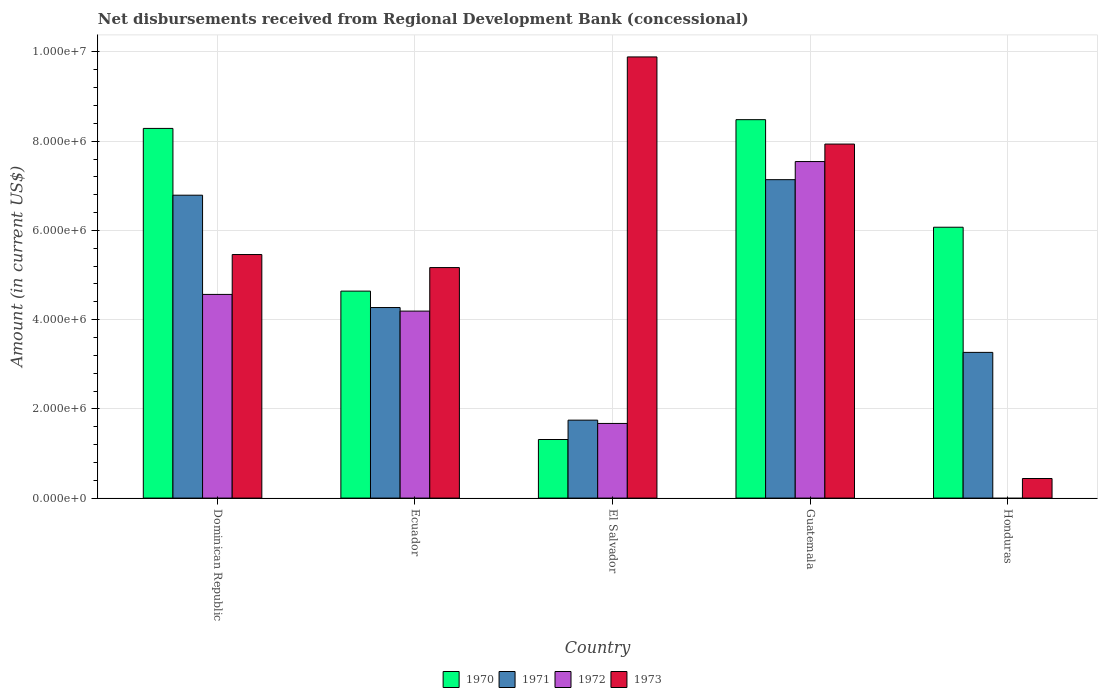How many groups of bars are there?
Your response must be concise. 5. Are the number of bars per tick equal to the number of legend labels?
Your answer should be compact. No. Are the number of bars on each tick of the X-axis equal?
Offer a terse response. No. How many bars are there on the 2nd tick from the left?
Make the answer very short. 4. What is the label of the 1st group of bars from the left?
Offer a very short reply. Dominican Republic. What is the amount of disbursements received from Regional Development Bank in 1970 in Ecuador?
Offer a very short reply. 4.64e+06. Across all countries, what is the maximum amount of disbursements received from Regional Development Bank in 1970?
Your answer should be compact. 8.48e+06. In which country was the amount of disbursements received from Regional Development Bank in 1973 maximum?
Your response must be concise. El Salvador. What is the total amount of disbursements received from Regional Development Bank in 1973 in the graph?
Your answer should be very brief. 2.89e+07. What is the difference between the amount of disbursements received from Regional Development Bank in 1973 in Ecuador and that in Guatemala?
Provide a short and direct response. -2.77e+06. What is the difference between the amount of disbursements received from Regional Development Bank in 1971 in Guatemala and the amount of disbursements received from Regional Development Bank in 1972 in Dominican Republic?
Your answer should be compact. 2.57e+06. What is the average amount of disbursements received from Regional Development Bank in 1973 per country?
Your answer should be compact. 5.78e+06. What is the difference between the amount of disbursements received from Regional Development Bank of/in 1971 and amount of disbursements received from Regional Development Bank of/in 1972 in Ecuador?
Keep it short and to the point. 8.00e+04. What is the ratio of the amount of disbursements received from Regional Development Bank in 1973 in El Salvador to that in Honduras?
Ensure brevity in your answer.  22.52. Is the difference between the amount of disbursements received from Regional Development Bank in 1971 in Dominican Republic and Ecuador greater than the difference between the amount of disbursements received from Regional Development Bank in 1972 in Dominican Republic and Ecuador?
Your answer should be compact. Yes. What is the difference between the highest and the second highest amount of disbursements received from Regional Development Bank in 1970?
Keep it short and to the point. 1.96e+05. What is the difference between the highest and the lowest amount of disbursements received from Regional Development Bank in 1971?
Provide a short and direct response. 5.39e+06. In how many countries, is the amount of disbursements received from Regional Development Bank in 1972 greater than the average amount of disbursements received from Regional Development Bank in 1972 taken over all countries?
Your answer should be compact. 3. How many countries are there in the graph?
Give a very brief answer. 5. What is the difference between two consecutive major ticks on the Y-axis?
Your answer should be very brief. 2.00e+06. Does the graph contain any zero values?
Offer a very short reply. Yes. Where does the legend appear in the graph?
Provide a short and direct response. Bottom center. How are the legend labels stacked?
Provide a short and direct response. Horizontal. What is the title of the graph?
Offer a terse response. Net disbursements received from Regional Development Bank (concessional). Does "1964" appear as one of the legend labels in the graph?
Provide a succinct answer. No. What is the label or title of the X-axis?
Ensure brevity in your answer.  Country. What is the label or title of the Y-axis?
Make the answer very short. Amount (in current US$). What is the Amount (in current US$) of 1970 in Dominican Republic?
Ensure brevity in your answer.  8.29e+06. What is the Amount (in current US$) of 1971 in Dominican Republic?
Offer a very short reply. 6.79e+06. What is the Amount (in current US$) in 1972 in Dominican Republic?
Provide a succinct answer. 4.56e+06. What is the Amount (in current US$) in 1973 in Dominican Republic?
Your answer should be compact. 5.46e+06. What is the Amount (in current US$) in 1970 in Ecuador?
Your answer should be very brief. 4.64e+06. What is the Amount (in current US$) in 1971 in Ecuador?
Ensure brevity in your answer.  4.27e+06. What is the Amount (in current US$) in 1972 in Ecuador?
Give a very brief answer. 4.19e+06. What is the Amount (in current US$) in 1973 in Ecuador?
Give a very brief answer. 5.17e+06. What is the Amount (in current US$) in 1970 in El Salvador?
Provide a short and direct response. 1.31e+06. What is the Amount (in current US$) in 1971 in El Salvador?
Offer a terse response. 1.75e+06. What is the Amount (in current US$) of 1972 in El Salvador?
Ensure brevity in your answer.  1.67e+06. What is the Amount (in current US$) in 1973 in El Salvador?
Provide a succinct answer. 9.89e+06. What is the Amount (in current US$) of 1970 in Guatemala?
Your response must be concise. 8.48e+06. What is the Amount (in current US$) in 1971 in Guatemala?
Keep it short and to the point. 7.14e+06. What is the Amount (in current US$) of 1972 in Guatemala?
Provide a short and direct response. 7.54e+06. What is the Amount (in current US$) of 1973 in Guatemala?
Provide a succinct answer. 7.94e+06. What is the Amount (in current US$) in 1970 in Honduras?
Offer a very short reply. 6.07e+06. What is the Amount (in current US$) of 1971 in Honduras?
Your answer should be compact. 3.27e+06. What is the Amount (in current US$) of 1973 in Honduras?
Your response must be concise. 4.39e+05. Across all countries, what is the maximum Amount (in current US$) of 1970?
Your answer should be very brief. 8.48e+06. Across all countries, what is the maximum Amount (in current US$) in 1971?
Ensure brevity in your answer.  7.14e+06. Across all countries, what is the maximum Amount (in current US$) in 1972?
Keep it short and to the point. 7.54e+06. Across all countries, what is the maximum Amount (in current US$) in 1973?
Keep it short and to the point. 9.89e+06. Across all countries, what is the minimum Amount (in current US$) in 1970?
Provide a succinct answer. 1.31e+06. Across all countries, what is the minimum Amount (in current US$) of 1971?
Keep it short and to the point. 1.75e+06. Across all countries, what is the minimum Amount (in current US$) in 1973?
Your response must be concise. 4.39e+05. What is the total Amount (in current US$) in 1970 in the graph?
Keep it short and to the point. 2.88e+07. What is the total Amount (in current US$) of 1971 in the graph?
Make the answer very short. 2.32e+07. What is the total Amount (in current US$) in 1972 in the graph?
Provide a succinct answer. 1.80e+07. What is the total Amount (in current US$) in 1973 in the graph?
Your answer should be compact. 2.89e+07. What is the difference between the Amount (in current US$) in 1970 in Dominican Republic and that in Ecuador?
Give a very brief answer. 3.65e+06. What is the difference between the Amount (in current US$) in 1971 in Dominican Republic and that in Ecuador?
Provide a succinct answer. 2.52e+06. What is the difference between the Amount (in current US$) in 1972 in Dominican Republic and that in Ecuador?
Provide a short and direct response. 3.74e+05. What is the difference between the Amount (in current US$) in 1973 in Dominican Republic and that in Ecuador?
Give a very brief answer. 2.92e+05. What is the difference between the Amount (in current US$) in 1970 in Dominican Republic and that in El Salvador?
Provide a short and direct response. 6.97e+06. What is the difference between the Amount (in current US$) of 1971 in Dominican Republic and that in El Salvador?
Provide a short and direct response. 5.04e+06. What is the difference between the Amount (in current US$) in 1972 in Dominican Republic and that in El Salvador?
Make the answer very short. 2.89e+06. What is the difference between the Amount (in current US$) of 1973 in Dominican Republic and that in El Salvador?
Your response must be concise. -4.43e+06. What is the difference between the Amount (in current US$) in 1970 in Dominican Republic and that in Guatemala?
Your answer should be very brief. -1.96e+05. What is the difference between the Amount (in current US$) in 1971 in Dominican Republic and that in Guatemala?
Your answer should be very brief. -3.48e+05. What is the difference between the Amount (in current US$) of 1972 in Dominican Republic and that in Guatemala?
Make the answer very short. -2.98e+06. What is the difference between the Amount (in current US$) of 1973 in Dominican Republic and that in Guatemala?
Keep it short and to the point. -2.48e+06. What is the difference between the Amount (in current US$) of 1970 in Dominican Republic and that in Honduras?
Make the answer very short. 2.22e+06. What is the difference between the Amount (in current US$) of 1971 in Dominican Republic and that in Honduras?
Provide a short and direct response. 3.52e+06. What is the difference between the Amount (in current US$) of 1973 in Dominican Republic and that in Honduras?
Ensure brevity in your answer.  5.02e+06. What is the difference between the Amount (in current US$) of 1970 in Ecuador and that in El Salvador?
Offer a very short reply. 3.33e+06. What is the difference between the Amount (in current US$) of 1971 in Ecuador and that in El Salvador?
Your answer should be compact. 2.52e+06. What is the difference between the Amount (in current US$) in 1972 in Ecuador and that in El Salvador?
Provide a short and direct response. 2.52e+06. What is the difference between the Amount (in current US$) of 1973 in Ecuador and that in El Salvador?
Your answer should be compact. -4.72e+06. What is the difference between the Amount (in current US$) of 1970 in Ecuador and that in Guatemala?
Your answer should be compact. -3.84e+06. What is the difference between the Amount (in current US$) in 1971 in Ecuador and that in Guatemala?
Your answer should be very brief. -2.87e+06. What is the difference between the Amount (in current US$) in 1972 in Ecuador and that in Guatemala?
Your response must be concise. -3.35e+06. What is the difference between the Amount (in current US$) in 1973 in Ecuador and that in Guatemala?
Provide a succinct answer. -2.77e+06. What is the difference between the Amount (in current US$) in 1970 in Ecuador and that in Honduras?
Keep it short and to the point. -1.43e+06. What is the difference between the Amount (in current US$) in 1971 in Ecuador and that in Honduras?
Make the answer very short. 1.00e+06. What is the difference between the Amount (in current US$) of 1973 in Ecuador and that in Honduras?
Provide a short and direct response. 4.73e+06. What is the difference between the Amount (in current US$) in 1970 in El Salvador and that in Guatemala?
Your answer should be compact. -7.17e+06. What is the difference between the Amount (in current US$) in 1971 in El Salvador and that in Guatemala?
Your response must be concise. -5.39e+06. What is the difference between the Amount (in current US$) of 1972 in El Salvador and that in Guatemala?
Keep it short and to the point. -5.87e+06. What is the difference between the Amount (in current US$) in 1973 in El Salvador and that in Guatemala?
Provide a succinct answer. 1.95e+06. What is the difference between the Amount (in current US$) in 1970 in El Salvador and that in Honduras?
Offer a very short reply. -4.76e+06. What is the difference between the Amount (in current US$) of 1971 in El Salvador and that in Honduras?
Give a very brief answer. -1.52e+06. What is the difference between the Amount (in current US$) in 1973 in El Salvador and that in Honduras?
Ensure brevity in your answer.  9.45e+06. What is the difference between the Amount (in current US$) of 1970 in Guatemala and that in Honduras?
Provide a short and direct response. 2.41e+06. What is the difference between the Amount (in current US$) in 1971 in Guatemala and that in Honduras?
Your answer should be very brief. 3.87e+06. What is the difference between the Amount (in current US$) in 1973 in Guatemala and that in Honduras?
Give a very brief answer. 7.50e+06. What is the difference between the Amount (in current US$) in 1970 in Dominican Republic and the Amount (in current US$) in 1971 in Ecuador?
Give a very brief answer. 4.02e+06. What is the difference between the Amount (in current US$) in 1970 in Dominican Republic and the Amount (in current US$) in 1972 in Ecuador?
Your answer should be very brief. 4.10e+06. What is the difference between the Amount (in current US$) in 1970 in Dominican Republic and the Amount (in current US$) in 1973 in Ecuador?
Provide a succinct answer. 3.12e+06. What is the difference between the Amount (in current US$) of 1971 in Dominican Republic and the Amount (in current US$) of 1972 in Ecuador?
Make the answer very short. 2.60e+06. What is the difference between the Amount (in current US$) in 1971 in Dominican Republic and the Amount (in current US$) in 1973 in Ecuador?
Your answer should be compact. 1.62e+06. What is the difference between the Amount (in current US$) of 1972 in Dominican Republic and the Amount (in current US$) of 1973 in Ecuador?
Give a very brief answer. -6.02e+05. What is the difference between the Amount (in current US$) of 1970 in Dominican Republic and the Amount (in current US$) of 1971 in El Salvador?
Give a very brief answer. 6.54e+06. What is the difference between the Amount (in current US$) in 1970 in Dominican Republic and the Amount (in current US$) in 1972 in El Salvador?
Provide a succinct answer. 6.61e+06. What is the difference between the Amount (in current US$) of 1970 in Dominican Republic and the Amount (in current US$) of 1973 in El Salvador?
Make the answer very short. -1.60e+06. What is the difference between the Amount (in current US$) in 1971 in Dominican Republic and the Amount (in current US$) in 1972 in El Salvador?
Your response must be concise. 5.12e+06. What is the difference between the Amount (in current US$) of 1971 in Dominican Republic and the Amount (in current US$) of 1973 in El Salvador?
Keep it short and to the point. -3.10e+06. What is the difference between the Amount (in current US$) in 1972 in Dominican Republic and the Amount (in current US$) in 1973 in El Salvador?
Make the answer very short. -5.32e+06. What is the difference between the Amount (in current US$) of 1970 in Dominican Republic and the Amount (in current US$) of 1971 in Guatemala?
Your answer should be compact. 1.15e+06. What is the difference between the Amount (in current US$) in 1970 in Dominican Republic and the Amount (in current US$) in 1972 in Guatemala?
Keep it short and to the point. 7.43e+05. What is the difference between the Amount (in current US$) of 1970 in Dominican Republic and the Amount (in current US$) of 1973 in Guatemala?
Offer a terse response. 3.51e+05. What is the difference between the Amount (in current US$) of 1971 in Dominican Republic and the Amount (in current US$) of 1972 in Guatemala?
Keep it short and to the point. -7.54e+05. What is the difference between the Amount (in current US$) of 1971 in Dominican Republic and the Amount (in current US$) of 1973 in Guatemala?
Your response must be concise. -1.15e+06. What is the difference between the Amount (in current US$) of 1972 in Dominican Republic and the Amount (in current US$) of 1973 in Guatemala?
Your answer should be compact. -3.37e+06. What is the difference between the Amount (in current US$) in 1970 in Dominican Republic and the Amount (in current US$) in 1971 in Honduras?
Give a very brief answer. 5.02e+06. What is the difference between the Amount (in current US$) in 1970 in Dominican Republic and the Amount (in current US$) in 1973 in Honduras?
Give a very brief answer. 7.85e+06. What is the difference between the Amount (in current US$) of 1971 in Dominican Republic and the Amount (in current US$) of 1973 in Honduras?
Keep it short and to the point. 6.35e+06. What is the difference between the Amount (in current US$) in 1972 in Dominican Republic and the Amount (in current US$) in 1973 in Honduras?
Ensure brevity in your answer.  4.13e+06. What is the difference between the Amount (in current US$) in 1970 in Ecuador and the Amount (in current US$) in 1971 in El Salvador?
Your answer should be compact. 2.89e+06. What is the difference between the Amount (in current US$) of 1970 in Ecuador and the Amount (in current US$) of 1972 in El Salvador?
Your answer should be compact. 2.97e+06. What is the difference between the Amount (in current US$) of 1970 in Ecuador and the Amount (in current US$) of 1973 in El Salvador?
Your answer should be compact. -5.25e+06. What is the difference between the Amount (in current US$) in 1971 in Ecuador and the Amount (in current US$) in 1972 in El Salvador?
Keep it short and to the point. 2.60e+06. What is the difference between the Amount (in current US$) in 1971 in Ecuador and the Amount (in current US$) in 1973 in El Salvador?
Provide a short and direct response. -5.62e+06. What is the difference between the Amount (in current US$) in 1972 in Ecuador and the Amount (in current US$) in 1973 in El Salvador?
Keep it short and to the point. -5.70e+06. What is the difference between the Amount (in current US$) of 1970 in Ecuador and the Amount (in current US$) of 1971 in Guatemala?
Give a very brief answer. -2.50e+06. What is the difference between the Amount (in current US$) of 1970 in Ecuador and the Amount (in current US$) of 1972 in Guatemala?
Offer a terse response. -2.90e+06. What is the difference between the Amount (in current US$) of 1970 in Ecuador and the Amount (in current US$) of 1973 in Guatemala?
Your answer should be very brief. -3.30e+06. What is the difference between the Amount (in current US$) in 1971 in Ecuador and the Amount (in current US$) in 1972 in Guatemala?
Provide a succinct answer. -3.27e+06. What is the difference between the Amount (in current US$) of 1971 in Ecuador and the Amount (in current US$) of 1973 in Guatemala?
Your answer should be very brief. -3.66e+06. What is the difference between the Amount (in current US$) in 1972 in Ecuador and the Amount (in current US$) in 1973 in Guatemala?
Keep it short and to the point. -3.74e+06. What is the difference between the Amount (in current US$) of 1970 in Ecuador and the Amount (in current US$) of 1971 in Honduras?
Provide a short and direct response. 1.37e+06. What is the difference between the Amount (in current US$) in 1970 in Ecuador and the Amount (in current US$) in 1973 in Honduras?
Keep it short and to the point. 4.20e+06. What is the difference between the Amount (in current US$) of 1971 in Ecuador and the Amount (in current US$) of 1973 in Honduras?
Make the answer very short. 3.83e+06. What is the difference between the Amount (in current US$) of 1972 in Ecuador and the Amount (in current US$) of 1973 in Honduras?
Give a very brief answer. 3.75e+06. What is the difference between the Amount (in current US$) in 1970 in El Salvador and the Amount (in current US$) in 1971 in Guatemala?
Ensure brevity in your answer.  -5.82e+06. What is the difference between the Amount (in current US$) in 1970 in El Salvador and the Amount (in current US$) in 1972 in Guatemala?
Your response must be concise. -6.23e+06. What is the difference between the Amount (in current US$) in 1970 in El Salvador and the Amount (in current US$) in 1973 in Guatemala?
Offer a terse response. -6.62e+06. What is the difference between the Amount (in current US$) in 1971 in El Salvador and the Amount (in current US$) in 1972 in Guatemala?
Keep it short and to the point. -5.80e+06. What is the difference between the Amount (in current US$) in 1971 in El Salvador and the Amount (in current US$) in 1973 in Guatemala?
Your answer should be very brief. -6.19e+06. What is the difference between the Amount (in current US$) in 1972 in El Salvador and the Amount (in current US$) in 1973 in Guatemala?
Your response must be concise. -6.26e+06. What is the difference between the Amount (in current US$) of 1970 in El Salvador and the Amount (in current US$) of 1971 in Honduras?
Make the answer very short. -1.95e+06. What is the difference between the Amount (in current US$) in 1970 in El Salvador and the Amount (in current US$) in 1973 in Honduras?
Your answer should be compact. 8.74e+05. What is the difference between the Amount (in current US$) in 1971 in El Salvador and the Amount (in current US$) in 1973 in Honduras?
Offer a terse response. 1.31e+06. What is the difference between the Amount (in current US$) of 1972 in El Salvador and the Amount (in current US$) of 1973 in Honduras?
Give a very brief answer. 1.23e+06. What is the difference between the Amount (in current US$) in 1970 in Guatemala and the Amount (in current US$) in 1971 in Honduras?
Ensure brevity in your answer.  5.22e+06. What is the difference between the Amount (in current US$) of 1970 in Guatemala and the Amount (in current US$) of 1973 in Honduras?
Ensure brevity in your answer.  8.04e+06. What is the difference between the Amount (in current US$) in 1971 in Guatemala and the Amount (in current US$) in 1973 in Honduras?
Your answer should be compact. 6.70e+06. What is the difference between the Amount (in current US$) in 1972 in Guatemala and the Amount (in current US$) in 1973 in Honduras?
Offer a very short reply. 7.10e+06. What is the average Amount (in current US$) of 1970 per country?
Your answer should be very brief. 5.76e+06. What is the average Amount (in current US$) of 1971 per country?
Offer a very short reply. 4.64e+06. What is the average Amount (in current US$) of 1972 per country?
Provide a short and direct response. 3.59e+06. What is the average Amount (in current US$) in 1973 per country?
Make the answer very short. 5.78e+06. What is the difference between the Amount (in current US$) of 1970 and Amount (in current US$) of 1971 in Dominican Republic?
Provide a succinct answer. 1.50e+06. What is the difference between the Amount (in current US$) in 1970 and Amount (in current US$) in 1972 in Dominican Republic?
Offer a terse response. 3.72e+06. What is the difference between the Amount (in current US$) of 1970 and Amount (in current US$) of 1973 in Dominican Republic?
Your answer should be compact. 2.83e+06. What is the difference between the Amount (in current US$) in 1971 and Amount (in current US$) in 1972 in Dominican Republic?
Give a very brief answer. 2.22e+06. What is the difference between the Amount (in current US$) of 1971 and Amount (in current US$) of 1973 in Dominican Republic?
Give a very brief answer. 1.33e+06. What is the difference between the Amount (in current US$) in 1972 and Amount (in current US$) in 1973 in Dominican Republic?
Give a very brief answer. -8.94e+05. What is the difference between the Amount (in current US$) of 1970 and Amount (in current US$) of 1971 in Ecuador?
Provide a succinct answer. 3.68e+05. What is the difference between the Amount (in current US$) of 1970 and Amount (in current US$) of 1972 in Ecuador?
Ensure brevity in your answer.  4.48e+05. What is the difference between the Amount (in current US$) of 1970 and Amount (in current US$) of 1973 in Ecuador?
Your response must be concise. -5.28e+05. What is the difference between the Amount (in current US$) in 1971 and Amount (in current US$) in 1972 in Ecuador?
Your answer should be very brief. 8.00e+04. What is the difference between the Amount (in current US$) in 1971 and Amount (in current US$) in 1973 in Ecuador?
Ensure brevity in your answer.  -8.96e+05. What is the difference between the Amount (in current US$) in 1972 and Amount (in current US$) in 1973 in Ecuador?
Provide a short and direct response. -9.76e+05. What is the difference between the Amount (in current US$) of 1970 and Amount (in current US$) of 1971 in El Salvador?
Offer a very short reply. -4.34e+05. What is the difference between the Amount (in current US$) in 1970 and Amount (in current US$) in 1972 in El Salvador?
Provide a short and direct response. -3.60e+05. What is the difference between the Amount (in current US$) of 1970 and Amount (in current US$) of 1973 in El Salvador?
Provide a succinct answer. -8.58e+06. What is the difference between the Amount (in current US$) in 1971 and Amount (in current US$) in 1972 in El Salvador?
Provide a short and direct response. 7.40e+04. What is the difference between the Amount (in current US$) of 1971 and Amount (in current US$) of 1973 in El Salvador?
Offer a terse response. -8.14e+06. What is the difference between the Amount (in current US$) in 1972 and Amount (in current US$) in 1973 in El Salvador?
Offer a very short reply. -8.22e+06. What is the difference between the Amount (in current US$) in 1970 and Amount (in current US$) in 1971 in Guatemala?
Offer a terse response. 1.34e+06. What is the difference between the Amount (in current US$) of 1970 and Amount (in current US$) of 1972 in Guatemala?
Your answer should be compact. 9.39e+05. What is the difference between the Amount (in current US$) of 1970 and Amount (in current US$) of 1973 in Guatemala?
Keep it short and to the point. 5.47e+05. What is the difference between the Amount (in current US$) in 1971 and Amount (in current US$) in 1972 in Guatemala?
Your answer should be very brief. -4.06e+05. What is the difference between the Amount (in current US$) of 1971 and Amount (in current US$) of 1973 in Guatemala?
Offer a very short reply. -7.98e+05. What is the difference between the Amount (in current US$) of 1972 and Amount (in current US$) of 1973 in Guatemala?
Provide a short and direct response. -3.92e+05. What is the difference between the Amount (in current US$) of 1970 and Amount (in current US$) of 1971 in Honduras?
Offer a very short reply. 2.80e+06. What is the difference between the Amount (in current US$) of 1970 and Amount (in current US$) of 1973 in Honduras?
Provide a succinct answer. 5.63e+06. What is the difference between the Amount (in current US$) of 1971 and Amount (in current US$) of 1973 in Honduras?
Give a very brief answer. 2.83e+06. What is the ratio of the Amount (in current US$) in 1970 in Dominican Republic to that in Ecuador?
Your response must be concise. 1.79. What is the ratio of the Amount (in current US$) in 1971 in Dominican Republic to that in Ecuador?
Provide a short and direct response. 1.59. What is the ratio of the Amount (in current US$) in 1972 in Dominican Republic to that in Ecuador?
Your answer should be compact. 1.09. What is the ratio of the Amount (in current US$) in 1973 in Dominican Republic to that in Ecuador?
Give a very brief answer. 1.06. What is the ratio of the Amount (in current US$) in 1970 in Dominican Republic to that in El Salvador?
Provide a short and direct response. 6.31. What is the ratio of the Amount (in current US$) in 1971 in Dominican Republic to that in El Salvador?
Provide a short and direct response. 3.89. What is the ratio of the Amount (in current US$) of 1972 in Dominican Republic to that in El Salvador?
Offer a very short reply. 2.73. What is the ratio of the Amount (in current US$) of 1973 in Dominican Republic to that in El Salvador?
Provide a short and direct response. 0.55. What is the ratio of the Amount (in current US$) in 1970 in Dominican Republic to that in Guatemala?
Your answer should be compact. 0.98. What is the ratio of the Amount (in current US$) of 1971 in Dominican Republic to that in Guatemala?
Your answer should be compact. 0.95. What is the ratio of the Amount (in current US$) of 1972 in Dominican Republic to that in Guatemala?
Offer a terse response. 0.61. What is the ratio of the Amount (in current US$) of 1973 in Dominican Republic to that in Guatemala?
Ensure brevity in your answer.  0.69. What is the ratio of the Amount (in current US$) in 1970 in Dominican Republic to that in Honduras?
Offer a very short reply. 1.36. What is the ratio of the Amount (in current US$) of 1971 in Dominican Republic to that in Honduras?
Your answer should be compact. 2.08. What is the ratio of the Amount (in current US$) of 1973 in Dominican Republic to that in Honduras?
Make the answer very short. 12.44. What is the ratio of the Amount (in current US$) in 1970 in Ecuador to that in El Salvador?
Provide a succinct answer. 3.53. What is the ratio of the Amount (in current US$) in 1971 in Ecuador to that in El Salvador?
Ensure brevity in your answer.  2.44. What is the ratio of the Amount (in current US$) of 1972 in Ecuador to that in El Salvador?
Give a very brief answer. 2.51. What is the ratio of the Amount (in current US$) of 1973 in Ecuador to that in El Salvador?
Offer a terse response. 0.52. What is the ratio of the Amount (in current US$) of 1970 in Ecuador to that in Guatemala?
Ensure brevity in your answer.  0.55. What is the ratio of the Amount (in current US$) in 1971 in Ecuador to that in Guatemala?
Make the answer very short. 0.6. What is the ratio of the Amount (in current US$) of 1972 in Ecuador to that in Guatemala?
Your answer should be very brief. 0.56. What is the ratio of the Amount (in current US$) of 1973 in Ecuador to that in Guatemala?
Make the answer very short. 0.65. What is the ratio of the Amount (in current US$) of 1970 in Ecuador to that in Honduras?
Your answer should be compact. 0.76. What is the ratio of the Amount (in current US$) of 1971 in Ecuador to that in Honduras?
Offer a very short reply. 1.31. What is the ratio of the Amount (in current US$) of 1973 in Ecuador to that in Honduras?
Keep it short and to the point. 11.77. What is the ratio of the Amount (in current US$) of 1970 in El Salvador to that in Guatemala?
Your answer should be compact. 0.15. What is the ratio of the Amount (in current US$) in 1971 in El Salvador to that in Guatemala?
Provide a succinct answer. 0.24. What is the ratio of the Amount (in current US$) in 1972 in El Salvador to that in Guatemala?
Ensure brevity in your answer.  0.22. What is the ratio of the Amount (in current US$) in 1973 in El Salvador to that in Guatemala?
Offer a terse response. 1.25. What is the ratio of the Amount (in current US$) in 1970 in El Salvador to that in Honduras?
Give a very brief answer. 0.22. What is the ratio of the Amount (in current US$) of 1971 in El Salvador to that in Honduras?
Your response must be concise. 0.53. What is the ratio of the Amount (in current US$) of 1973 in El Salvador to that in Honduras?
Offer a very short reply. 22.52. What is the ratio of the Amount (in current US$) in 1970 in Guatemala to that in Honduras?
Offer a very short reply. 1.4. What is the ratio of the Amount (in current US$) of 1971 in Guatemala to that in Honduras?
Give a very brief answer. 2.19. What is the ratio of the Amount (in current US$) of 1973 in Guatemala to that in Honduras?
Give a very brief answer. 18.08. What is the difference between the highest and the second highest Amount (in current US$) in 1970?
Ensure brevity in your answer.  1.96e+05. What is the difference between the highest and the second highest Amount (in current US$) in 1971?
Keep it short and to the point. 3.48e+05. What is the difference between the highest and the second highest Amount (in current US$) of 1972?
Offer a terse response. 2.98e+06. What is the difference between the highest and the second highest Amount (in current US$) of 1973?
Ensure brevity in your answer.  1.95e+06. What is the difference between the highest and the lowest Amount (in current US$) of 1970?
Provide a succinct answer. 7.17e+06. What is the difference between the highest and the lowest Amount (in current US$) in 1971?
Your response must be concise. 5.39e+06. What is the difference between the highest and the lowest Amount (in current US$) of 1972?
Keep it short and to the point. 7.54e+06. What is the difference between the highest and the lowest Amount (in current US$) of 1973?
Your response must be concise. 9.45e+06. 